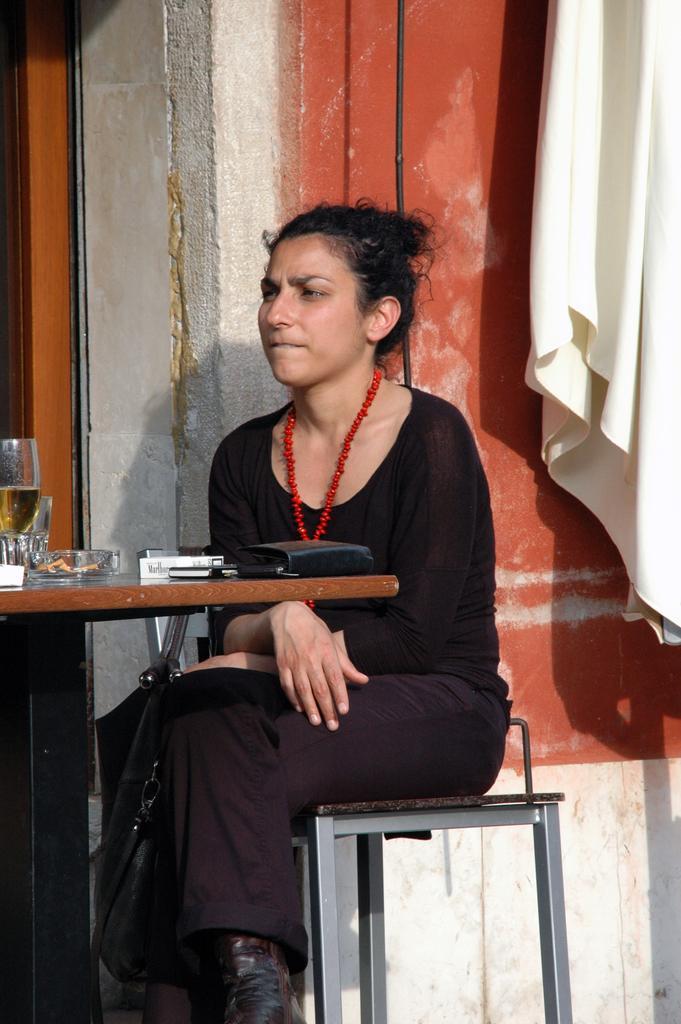Please provide a concise description of this image. In this picture there is a woman wearing a black color dress is sitting on the chair. In the front there is a table on which a black purse, ashtray and wine glass is placed. Behind there is a white wall and red color window. 